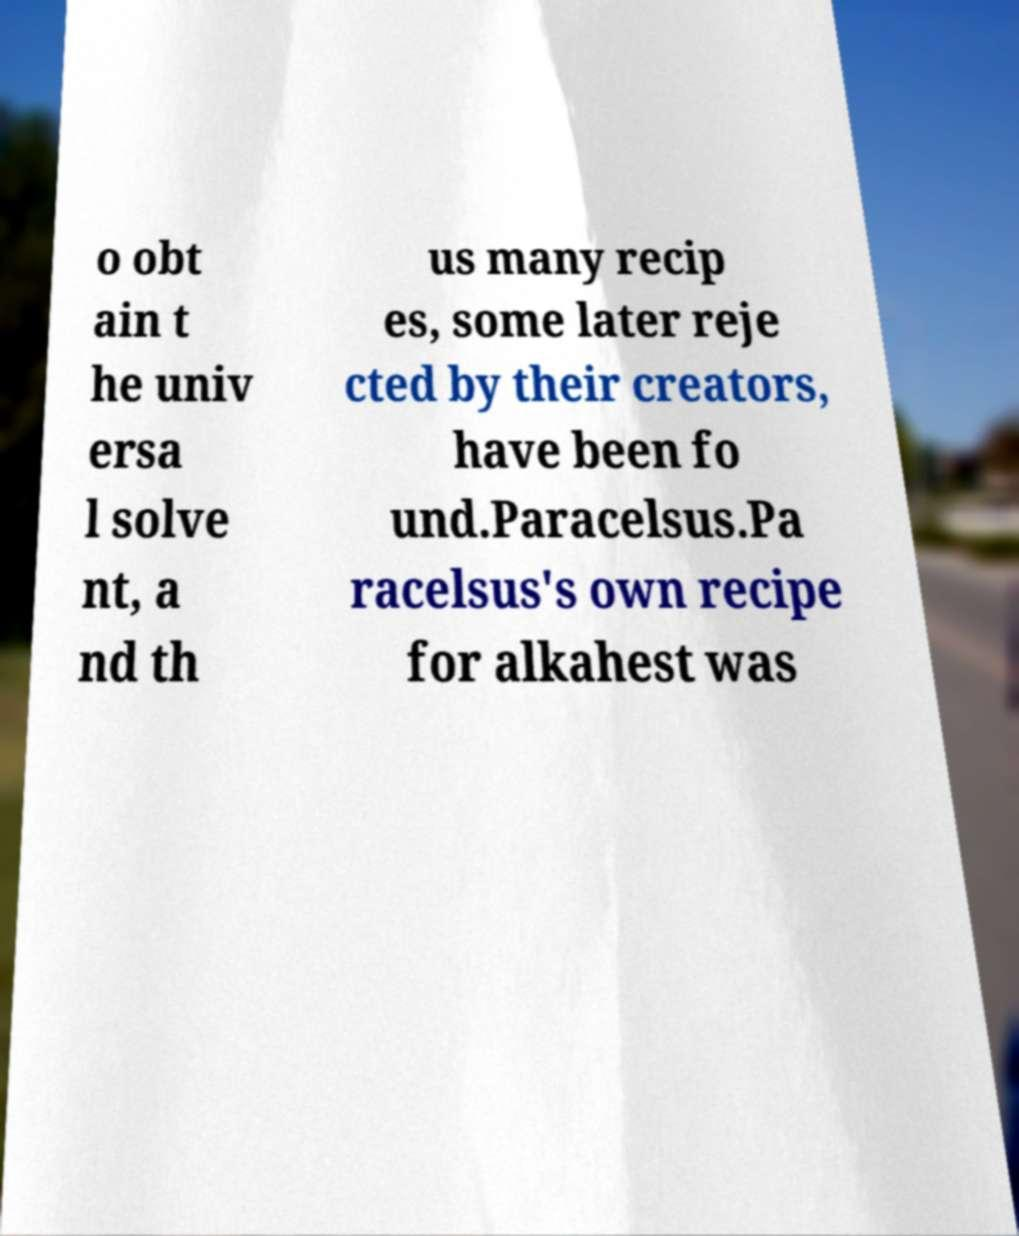Please identify and transcribe the text found in this image. o obt ain t he univ ersa l solve nt, a nd th us many recip es, some later reje cted by their creators, have been fo und.Paracelsus.Pa racelsus's own recipe for alkahest was 